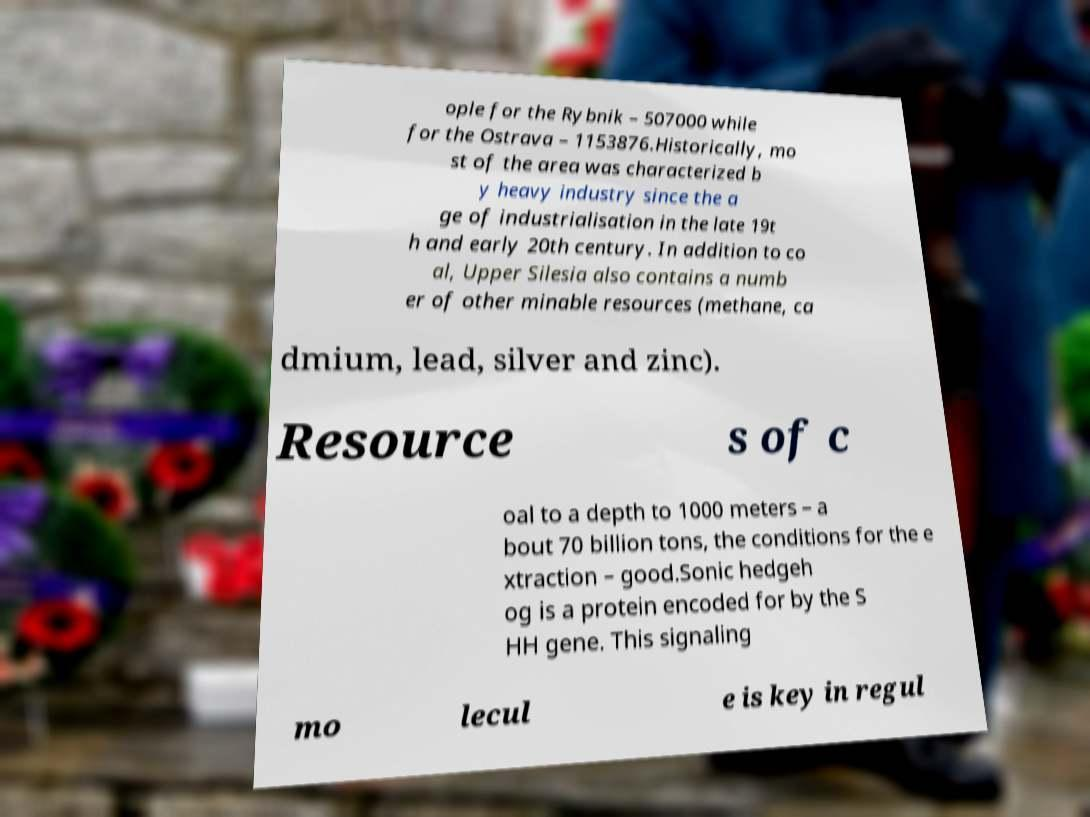What messages or text are displayed in this image? I need them in a readable, typed format. ople for the Rybnik – 507000 while for the Ostrava – 1153876.Historically, mo st of the area was characterized b y heavy industry since the a ge of industrialisation in the late 19t h and early 20th century. In addition to co al, Upper Silesia also contains a numb er of other minable resources (methane, ca dmium, lead, silver and zinc). Resource s of c oal to a depth to 1000 meters – a bout 70 billion tons, the conditions for the e xtraction – good.Sonic hedgeh og is a protein encoded for by the S HH gene. This signaling mo lecul e is key in regul 